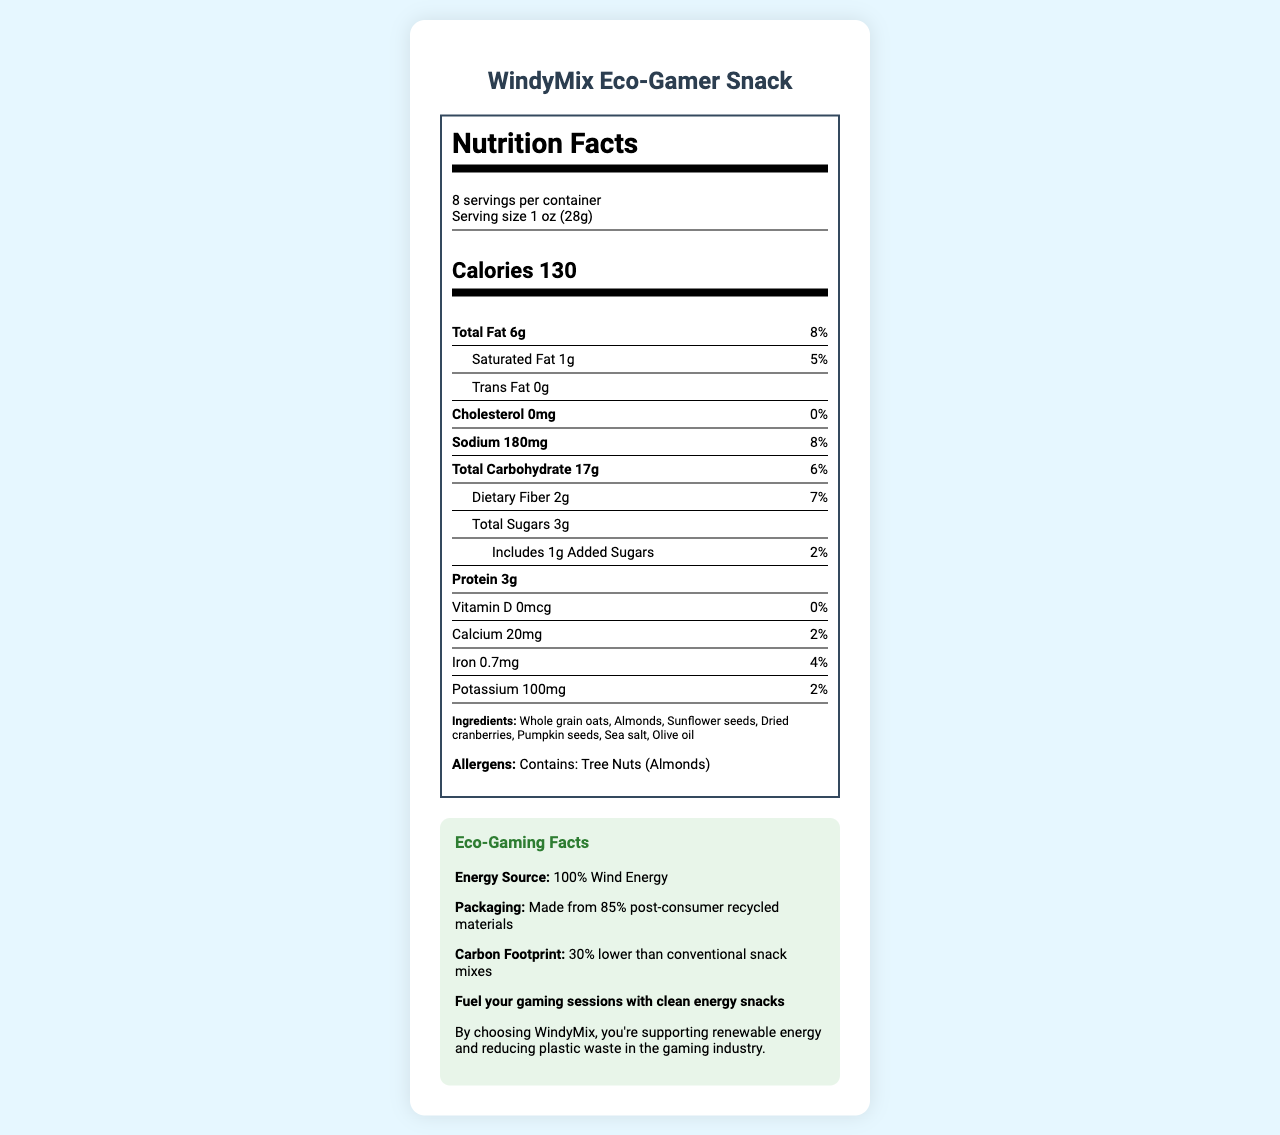what is the serving size? The serving size is clearly stated at the top of the nutrition facts label.
Answer: 1 oz (28g) how many servings per container? The document specifies that there are 8 servings per container.
Answer: 8 how many calories are in one serving? The calorie count per serving is listed prominently in the document.
Answer: 130 what is the total fat content per serving? The total fat content is specified as 6g per serving in the nutrition facts section.
Answer: 6g what percentage of the daily value is the sodium content? The sodium content per serving is 180mg, which is 8% of the daily value as noted in the document.
Answer: 8% which ingredient is listed first? The first ingredient listed in the ingredients section is Whole grain oats.
Answer: Whole grain oats how much dietary fiber does one serving contain? The dietary fiber content per serving is listed as 2g in the nutrition facts.
Answer: 2g what is the amount of added sugars per serving? The nutrition facts label indicates that there is 1g of added sugars per serving.
Answer: 1g does the product contain any allergens? The document lists tree nuts (almonds) as an allergen in the allergens section.
Answer: Yes what are the eco facts about this product? The eco facts section provides information about energy source, packaging, and carbon footprint.
Answer: Energy Source: 100% Wind Energy, Packaging: Made from 85% post-consumer recycled materials, Carbon Footprint: 30% lower than conventional snack mixes what type of seeds are included in the ingredient list? The ingredient list mentions both sunflower seeds and pumpkin seeds.
Answer: Sunflower seeds and pumpkin seeds which vitamin and mineral are completely absent in the product? The document shows that vitamin D has an amount of 0mcg and a daily value of 0%.
Answer: Vitamin D how much calcium is there in one serving? A. 0mg B. 20mg C. 100mg D. 200mg The nutrition facts states that there are 20mg of calcium per serving.
Answer: B what energy source does the product use in its production? A. Solar B. Wind C. Hydro The eco facts section specifies that this product uses 100% wind energy.
Answer: B what is the main idea of this document? The document covers multiple aspects including nutritional facts, ingredients, allergens, eco-facts, sustainable practices, and their connection to gaming.
Answer: The document provides the nutritional information, ingredients, allergens, and eco-facts for the WindyMix Eco-Gamer Snack. It emphasizes the use of renewable wind energy in production and recycled materials in packaging, aiming to support both healthy snacking and environmental sustainability. what is the protein content per serving? The nutrition facts label indicates that there are 3g of protein per serving.
Answer: 3g what is the carbon footprint reduction compared to conventional snack mixes? The eco facts section mentions that the carbon footprint is 30% lower compared to conventional snack mixes.
Answer: 30% lower are there any sources of saturated fat listed? The document lists saturated fat as 1g per serving which is 5% of the daily value.
Answer: Yes which vitamin has the highest daily value percentage? Iron has the highest daily value percentage among vitamins and minerals listed, at 4%.
Answer: Iron what specific information about production costs did the document provide? The document does not include any details regarding the production costs.
Answer: Not enough information 